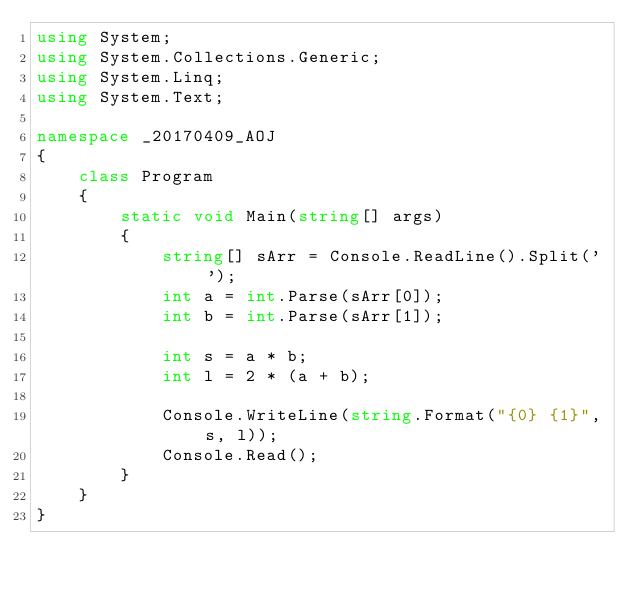<code> <loc_0><loc_0><loc_500><loc_500><_C#_>using System;
using System.Collections.Generic;
using System.Linq;
using System.Text;

namespace _20170409_AOJ
{
    class Program
    {
        static void Main(string[] args)
        {
            string[] sArr = Console.ReadLine().Split(' ');
            int a = int.Parse(sArr[0]);
            int b = int.Parse(sArr[1]);

            int s = a * b;
            int l = 2 * (a + b);

            Console.WriteLine(string.Format("{0} {1}", s, l));
            Console.Read();
        }
    }
}</code> 